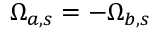Convert formula to latex. <formula><loc_0><loc_0><loc_500><loc_500>\Omega _ { a , s } = - \Omega _ { b , s }</formula> 